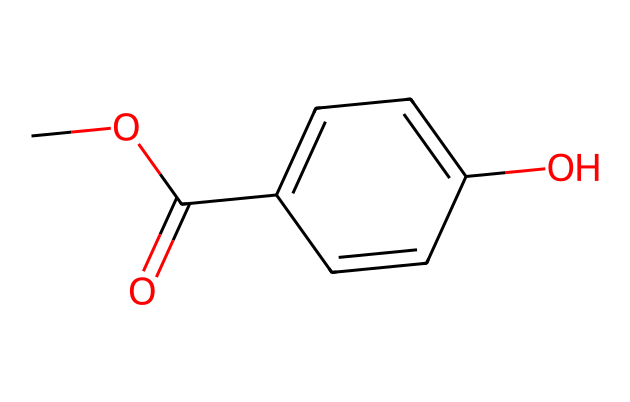What is the total number of carbon atoms in methylparaben? Counting the carbon atoms in the SMILES representation, we identify five "C" characters. Therefore, there are five carbon atoms in the structure.
Answer: five How many oxygen atoms are present in the structure? In the given SMILES representation, there are two "O" characters present. Therefore, there are two oxygen atoms in the structure.
Answer: two What functional group is represented by the “COC(=O)” part of the structure? The "COC(=O)" indicates the presence of an ester functional group due to the combination of a carbonyl (C=O) and an ether (C-O-C) connection.
Answer: ester What type of reaction would methylparaben undergo to break it down? Methylparaben can undergo hydrolysis due to its ester group, where water would break the ester bond.
Answer: hydrolysis What type of chemical is methylparaben categorized as? Given its role and structure, methylparaben is categorized as a preservative, commonly used to inhibit microbial growth in cosmetics.
Answer: preservative Which part of the molecule contributes to its antimicrobial activity? The para-hydroxyphenyl part of the molecule contains hydroxyl groups that enhance its ability to interact with microbial enzymes, contributing to its antimicrobial activity.
Answer: para-hydroxyphenyl What is the ring structure present in methylparaben? The ring structure in methylparaben is a benzene ring, indicated by the alternating single and double bonds in the circular carbon structure.
Answer: benzene ring 